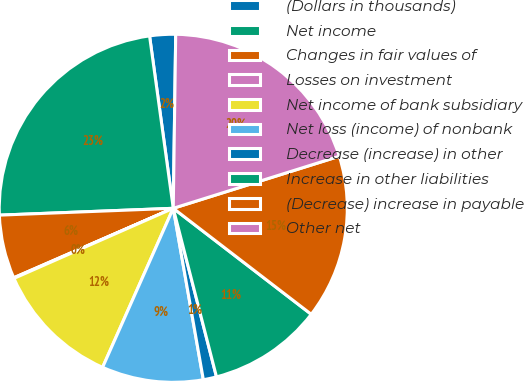Convert chart. <chart><loc_0><loc_0><loc_500><loc_500><pie_chart><fcel>(Dollars in thousands)<fcel>Net income<fcel>Changes in fair values of<fcel>Losses on investment<fcel>Net income of bank subsidiary<fcel>Net loss (income) of nonbank<fcel>Decrease (increase) in other<fcel>Increase in other liabilities<fcel>(Decrease) increase in payable<fcel>Other net<nl><fcel>2.4%<fcel>23.45%<fcel>5.91%<fcel>0.06%<fcel>11.75%<fcel>9.42%<fcel>1.23%<fcel>10.58%<fcel>15.26%<fcel>19.94%<nl></chart> 